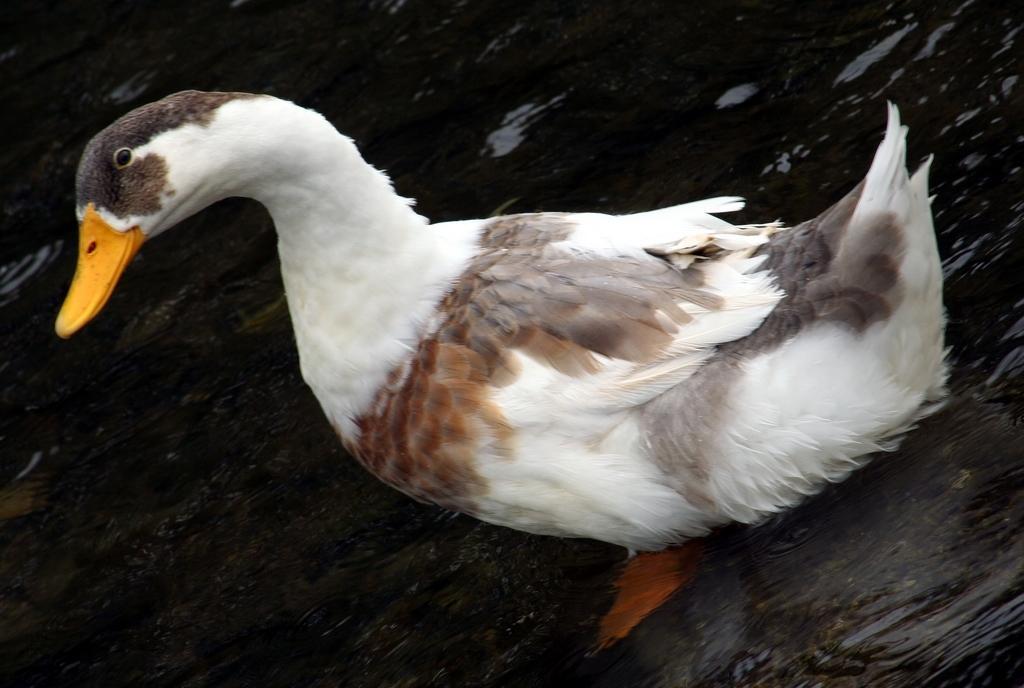In one or two sentences, can you explain what this image depicts? In this picture I can see a duck in the water. 